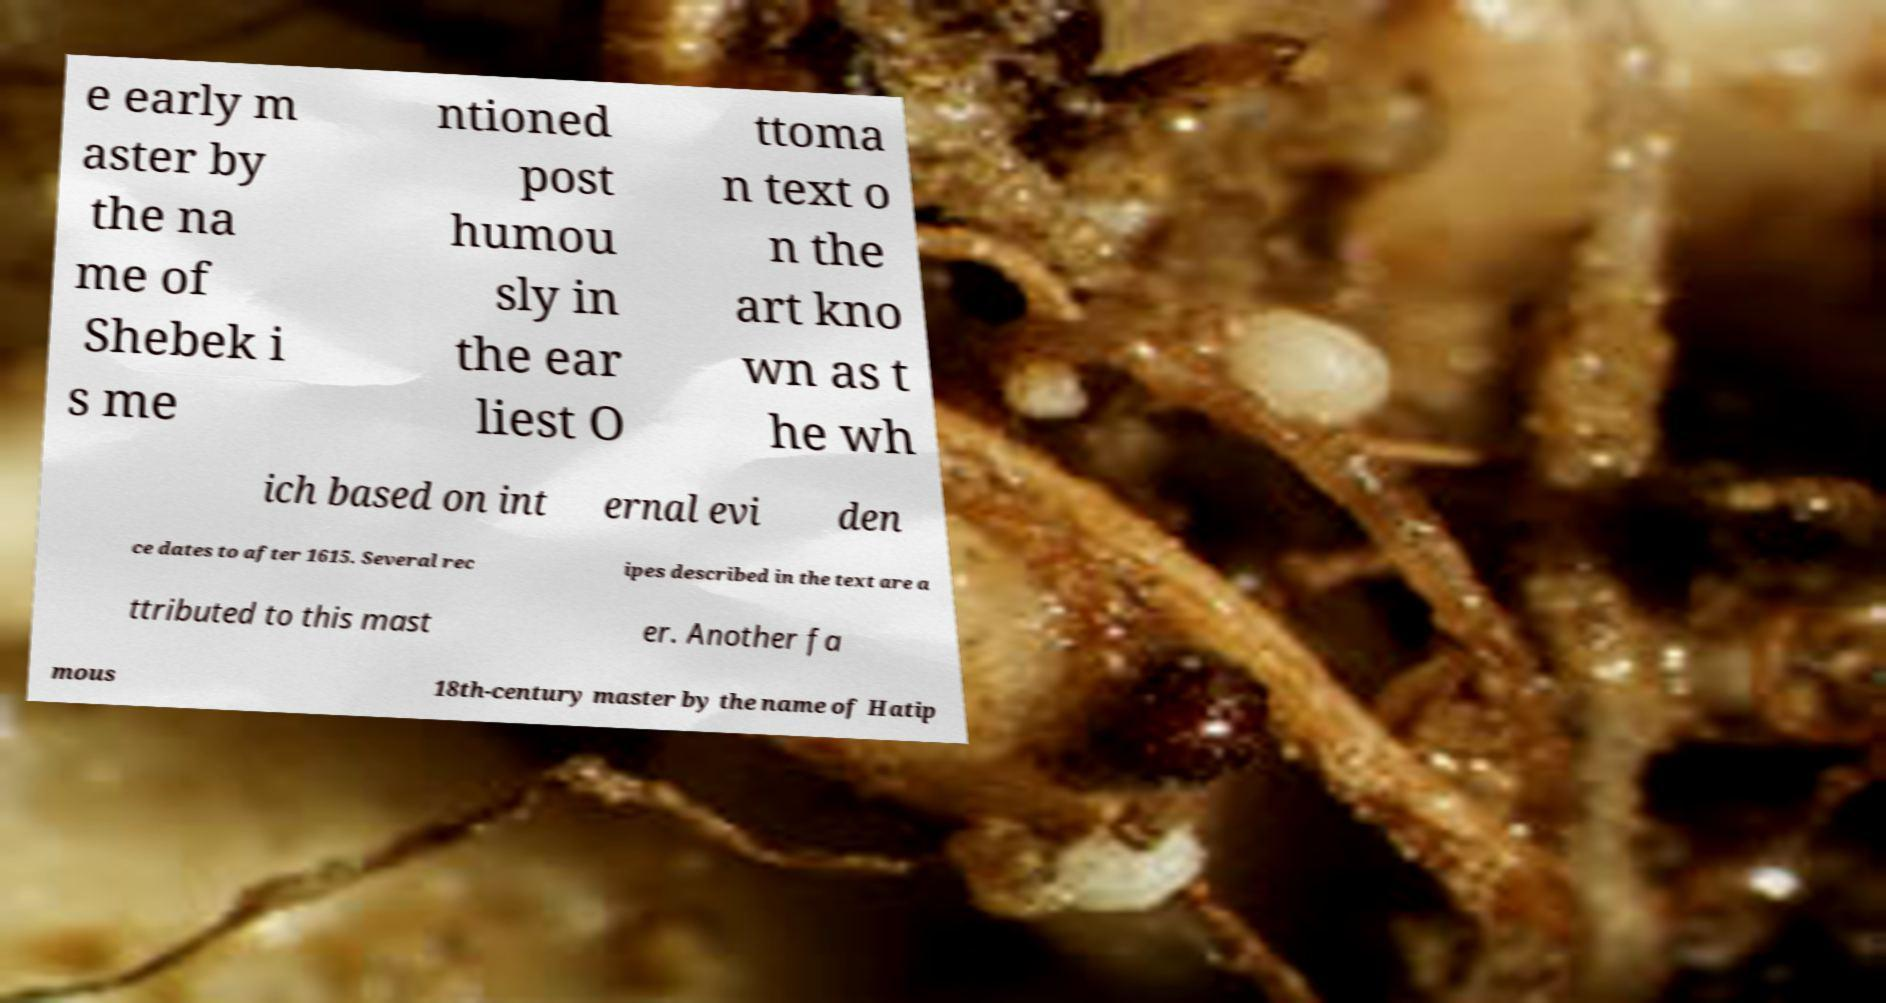Please read and relay the text visible in this image. What does it say? e early m aster by the na me of Shebek i s me ntioned post humou sly in the ear liest O ttoma n text o n the art kno wn as t he wh ich based on int ernal evi den ce dates to after 1615. Several rec ipes described in the text are a ttributed to this mast er. Another fa mous 18th-century master by the name of Hatip 